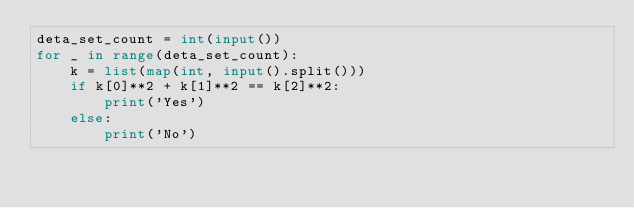<code> <loc_0><loc_0><loc_500><loc_500><_Python_>deta_set_count = int(input())
for _ in range(deta_set_count):
    k = list(map(int, input().split()))
    if k[0]**2 + k[1]**2 == k[2]**2:
        print('Yes')
    else:
        print('No')</code> 